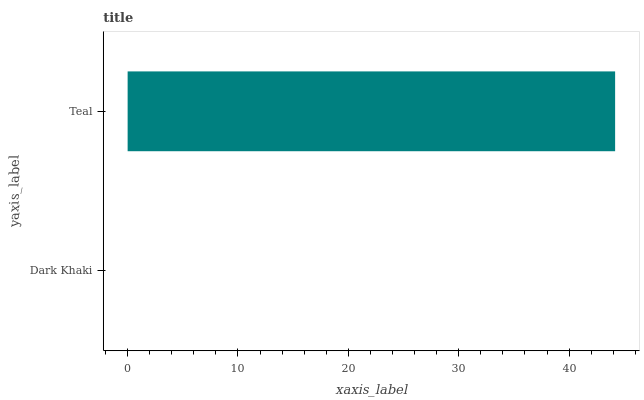Is Dark Khaki the minimum?
Answer yes or no. Yes. Is Teal the maximum?
Answer yes or no. Yes. Is Teal the minimum?
Answer yes or no. No. Is Teal greater than Dark Khaki?
Answer yes or no. Yes. Is Dark Khaki less than Teal?
Answer yes or no. Yes. Is Dark Khaki greater than Teal?
Answer yes or no. No. Is Teal less than Dark Khaki?
Answer yes or no. No. Is Teal the high median?
Answer yes or no. Yes. Is Dark Khaki the low median?
Answer yes or no. Yes. Is Dark Khaki the high median?
Answer yes or no. No. Is Teal the low median?
Answer yes or no. No. 